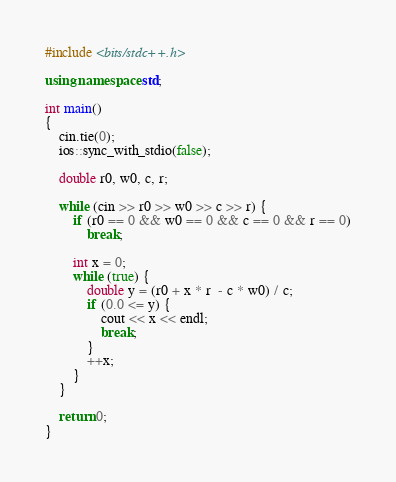<code> <loc_0><loc_0><loc_500><loc_500><_C++_>#include <bits/stdc++.h>

using namespace std;

int main()
{
    cin.tie(0);
    ios::sync_with_stdio(false);

    double r0, w0, c, r;

    while (cin >> r0 >> w0 >> c >> r) {
        if (r0 == 0 && w0 == 0 && c == 0 && r == 0)
            break;

        int x = 0;
        while (true) {
            double y = (r0 + x * r  - c * w0) / c;
            if (0.0 <= y) {
                cout << x << endl;
                break;
            }
            ++x;
        }
    }

    return 0;
}</code> 